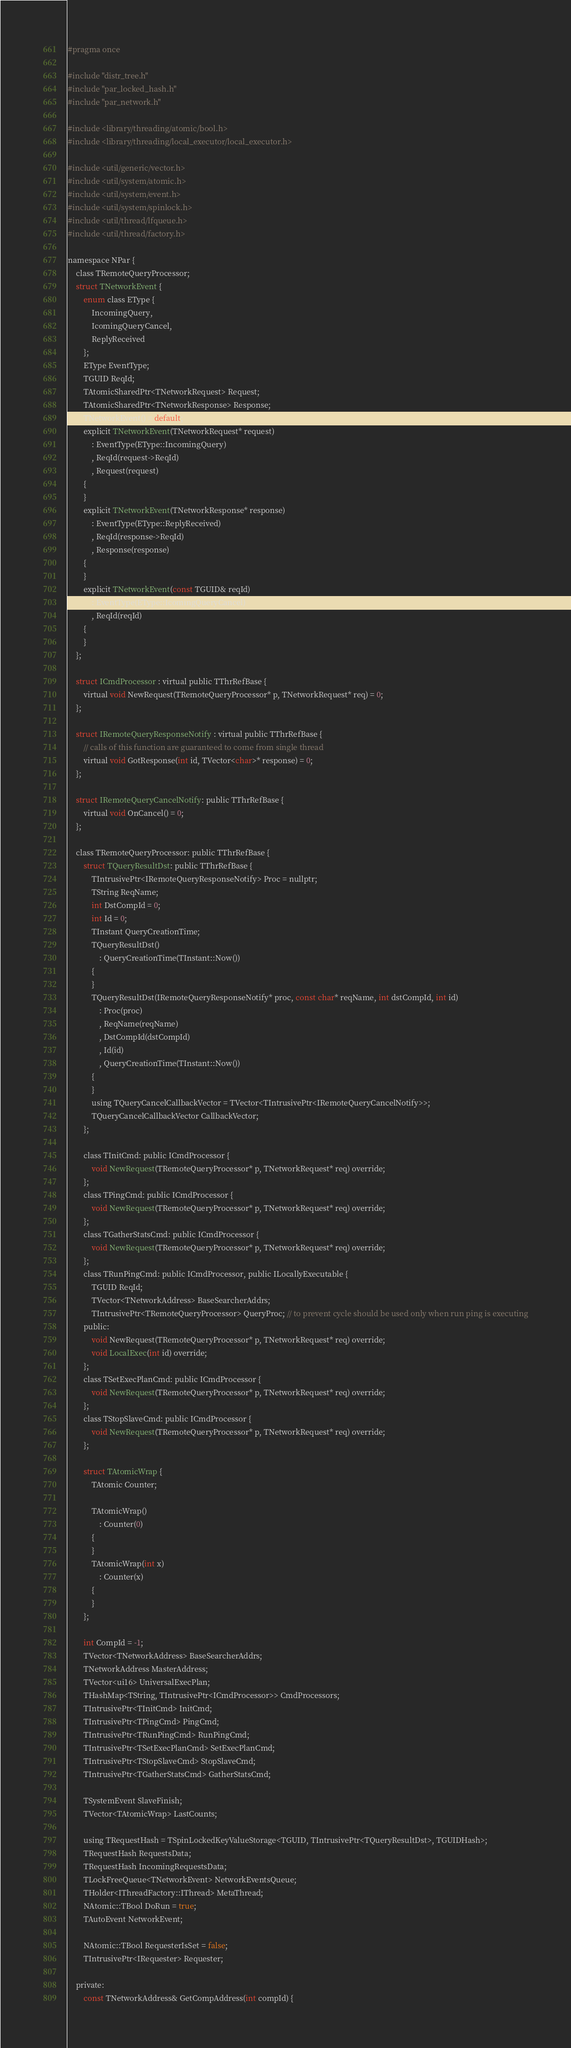<code> <loc_0><loc_0><loc_500><loc_500><_C_>#pragma once

#include "distr_tree.h"
#include "par_locked_hash.h"
#include "par_network.h"

#include <library/threading/atomic/bool.h>
#include <library/threading/local_executor/local_executor.h>

#include <util/generic/vector.h>
#include <util/system/atomic.h>
#include <util/system/event.h>
#include <util/system/spinlock.h>
#include <util/thread/lfqueue.h>
#include <util/thread/factory.h>

namespace NPar {
    class TRemoteQueryProcessor;
    struct TNetworkEvent {
        enum class EType {
            IncomingQuery,
            IcomingQueryCancel,
            ReplyReceived
        };
        EType EventType;
        TGUID ReqId;
        TAtomicSharedPtr<TNetworkRequest> Request;
        TAtomicSharedPtr<TNetworkResponse> Response;
        TNetworkEvent() = default;
        explicit TNetworkEvent(TNetworkRequest* request)
            : EventType(EType::IncomingQuery)
            , ReqId(request->ReqId)
            , Request(request)
        {
        }
        explicit TNetworkEvent(TNetworkResponse* response)
            : EventType(EType::ReplyReceived)
            , ReqId(response->ReqId)
            , Response(response)
        {
        }
        explicit TNetworkEvent(const TGUID& reqId)
            : EventType(EType::IcomingQueryCancel)
            , ReqId(reqId)
        {
        }
    };

    struct ICmdProcessor : virtual public TThrRefBase {
        virtual void NewRequest(TRemoteQueryProcessor* p, TNetworkRequest* req) = 0;
    };

    struct IRemoteQueryResponseNotify : virtual public TThrRefBase {
        // calls of this function are guaranteed to come from single thread
        virtual void GotResponse(int id, TVector<char>* response) = 0;
    };

    struct IRemoteQueryCancelNotify: public TThrRefBase {
        virtual void OnCancel() = 0;
    };

    class TRemoteQueryProcessor: public TThrRefBase {
        struct TQueryResultDst: public TThrRefBase {
            TIntrusivePtr<IRemoteQueryResponseNotify> Proc = nullptr;
            TString ReqName;
            int DstCompId = 0;
            int Id = 0;
            TInstant QueryCreationTime;
            TQueryResultDst()
                : QueryCreationTime(TInstant::Now())
            {
            }
            TQueryResultDst(IRemoteQueryResponseNotify* proc, const char* reqName, int dstCompId, int id)
                : Proc(proc)
                , ReqName(reqName)
                , DstCompId(dstCompId)
                , Id(id)
                , QueryCreationTime(TInstant::Now())
            {
            }
            using TQueryCancelCallbackVector = TVector<TIntrusivePtr<IRemoteQueryCancelNotify>>;
            TQueryCancelCallbackVector CallbackVector;
        };

        class TInitCmd: public ICmdProcessor {
            void NewRequest(TRemoteQueryProcessor* p, TNetworkRequest* req) override;
        };
        class TPingCmd: public ICmdProcessor {
            void NewRequest(TRemoteQueryProcessor* p, TNetworkRequest* req) override;
        };
        class TGatherStatsCmd: public ICmdProcessor {
            void NewRequest(TRemoteQueryProcessor* p, TNetworkRequest* req) override;
        };
        class TRunPingCmd: public ICmdProcessor, public ILocallyExecutable {
            TGUID ReqId;
            TVector<TNetworkAddress> BaseSearcherAddrs;
            TIntrusivePtr<TRemoteQueryProcessor> QueryProc; // to prevent cycle should be used only when run ping is executing
        public:
            void NewRequest(TRemoteQueryProcessor* p, TNetworkRequest* req) override;
            void LocalExec(int id) override;
        };
        class TSetExecPlanCmd: public ICmdProcessor {
            void NewRequest(TRemoteQueryProcessor* p, TNetworkRequest* req) override;
        };
        class TStopSlaveCmd: public ICmdProcessor {
            void NewRequest(TRemoteQueryProcessor* p, TNetworkRequest* req) override;
        };

        struct TAtomicWrap {
            TAtomic Counter;

            TAtomicWrap()
                : Counter(0)
            {
            }
            TAtomicWrap(int x)
                : Counter(x)
            {
            }
        };

        int CompId = -1;
        TVector<TNetworkAddress> BaseSearcherAddrs;
        TNetworkAddress MasterAddress;
        TVector<ui16> UniversalExecPlan;
        THashMap<TString, TIntrusivePtr<ICmdProcessor>> CmdProcessors;
        TIntrusivePtr<TInitCmd> InitCmd;
        TIntrusivePtr<TPingCmd> PingCmd;
        TIntrusivePtr<TRunPingCmd> RunPingCmd;
        TIntrusivePtr<TSetExecPlanCmd> SetExecPlanCmd;
        TIntrusivePtr<TStopSlaveCmd> StopSlaveCmd;
        TIntrusivePtr<TGatherStatsCmd> GatherStatsCmd;

        TSystemEvent SlaveFinish;
        TVector<TAtomicWrap> LastCounts;

        using TRequestHash = TSpinLockedKeyValueStorage<TGUID, TIntrusivePtr<TQueryResultDst>, TGUIDHash>;
        TRequestHash RequestsData;
        TRequestHash IncomingRequestsData;
        TLockFreeQueue<TNetworkEvent> NetworkEventsQueue;
        THolder<IThreadFactory::IThread> MetaThread;
        NAtomic::TBool DoRun = true;
        TAutoEvent NetworkEvent;

        NAtomic::TBool RequesterIsSet = false;
        TIntrusivePtr<IRequester> Requester;

    private:
        const TNetworkAddress& GetCompAddress(int compId) {</code> 